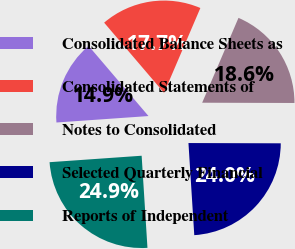Convert chart to OTSL. <chart><loc_0><loc_0><loc_500><loc_500><pie_chart><fcel>Consolidated Balance Sheets as<fcel>Consolidated Statements of<fcel>Notes to Consolidated<fcel>Selected Quarterly Financial<fcel>Reports of Independent<nl><fcel>14.87%<fcel>17.68%<fcel>18.61%<fcel>23.95%<fcel>24.89%<nl></chart> 